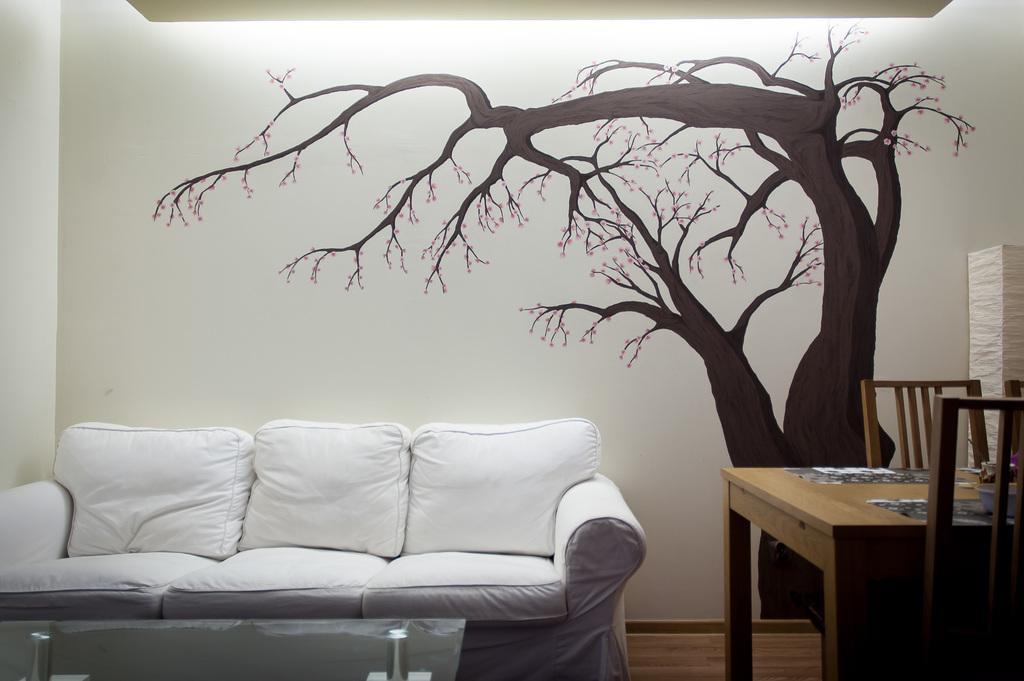Describe this image in one or two sentences. In this image i can see a sofa, a wall with the tree painting, a table and two chairs. 